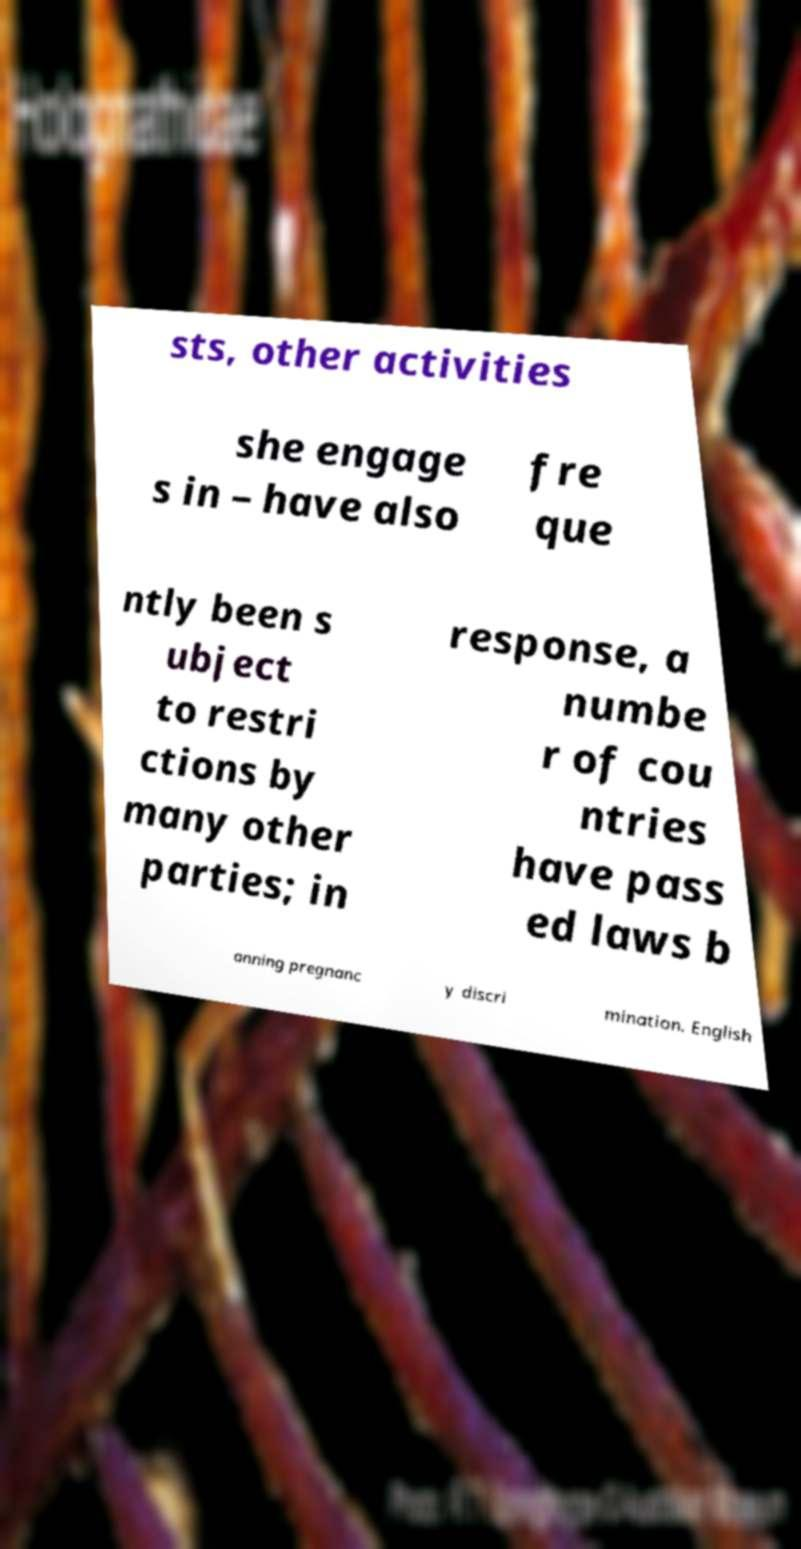I need the written content from this picture converted into text. Can you do that? sts, other activities she engage s in – have also fre que ntly been s ubject to restri ctions by many other parties; in response, a numbe r of cou ntries have pass ed laws b anning pregnanc y discri mination. English 